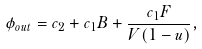<formula> <loc_0><loc_0><loc_500><loc_500>\phi _ { o u t } = c _ { 2 } + c _ { 1 } B + \frac { c _ { 1 } F } { V ( 1 - u ) } ,</formula> 